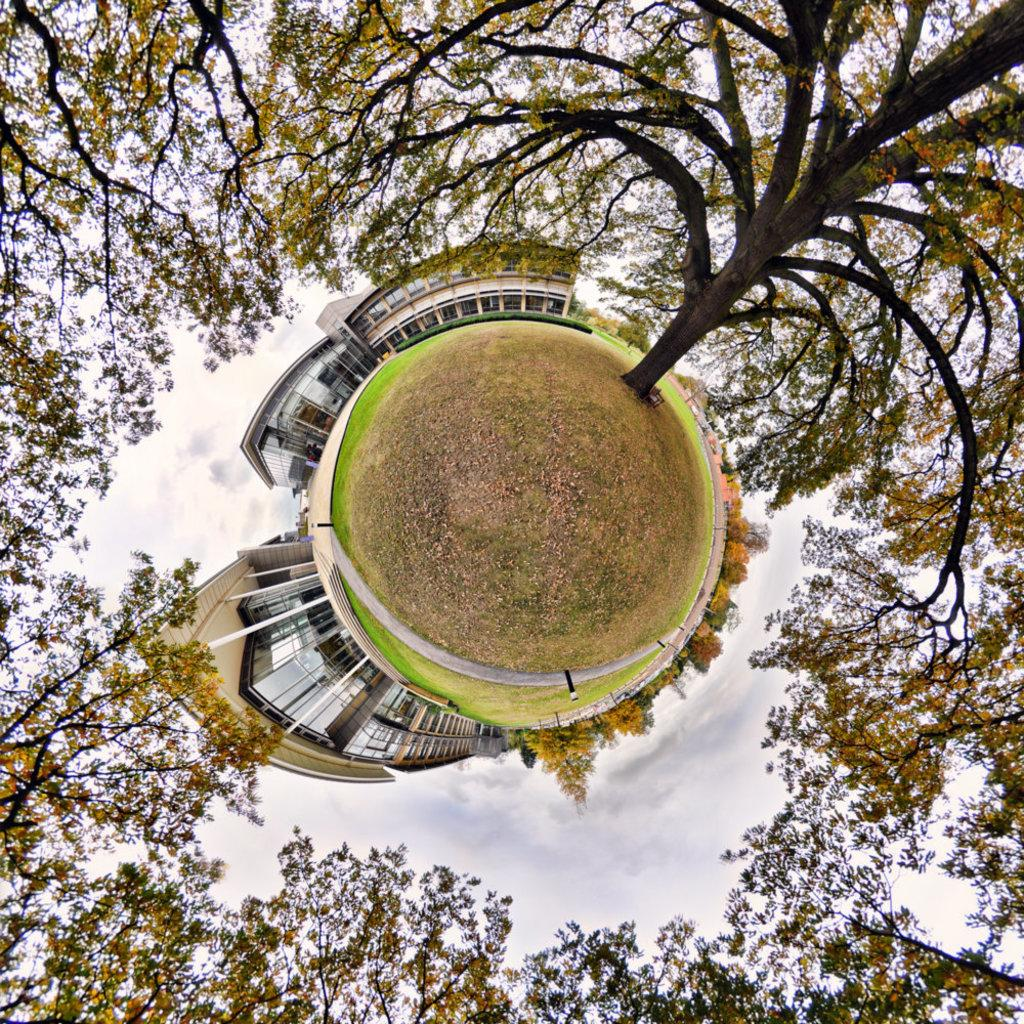What type of vegetation can be seen in the image? There are trees in the image. What is the surface on which the trees are standing? There is a ground in the image. What type of man-made structures are visible in the image? There are buildings in the image. What level of control does the tree have over the buildings in the image? The tree does not have any control over the buildings in the image, as they are separate entities. 